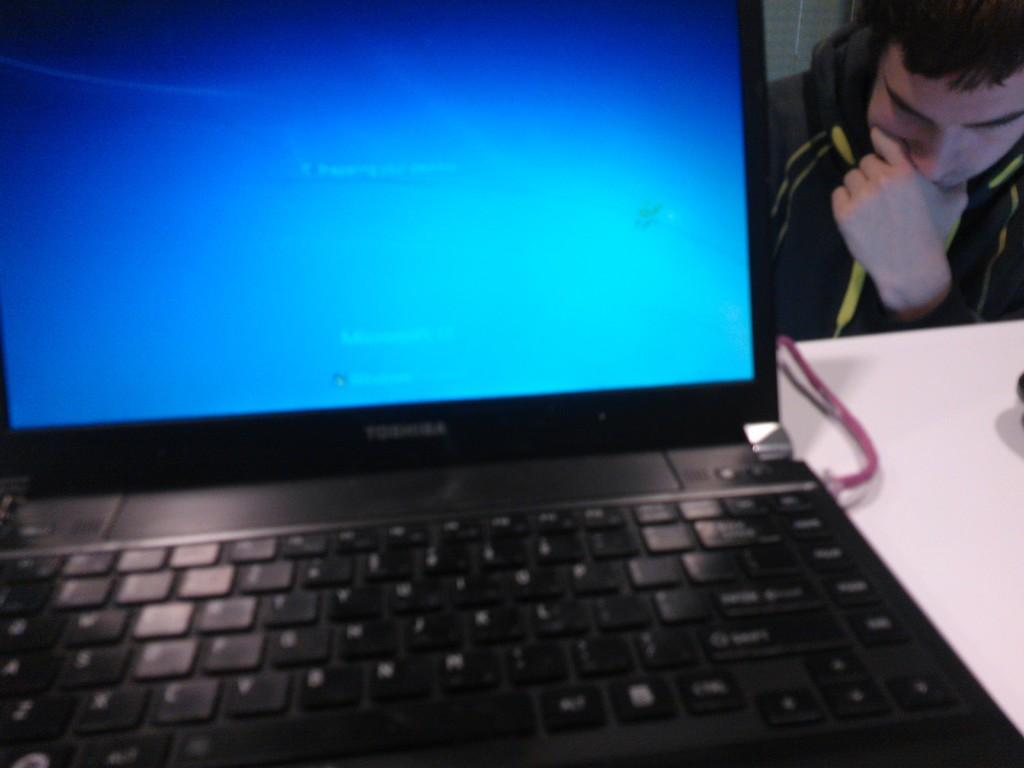What electronic device is on the table in the image? There is a laptop on a table in the image. What is the person in the image doing? The person is sitting on a chair in the image. What type of notebook is the person using in the image? There is no notebook present in the image; the person is using a laptop. What badge is the person wearing in the image? There is no badge visible in the image. 